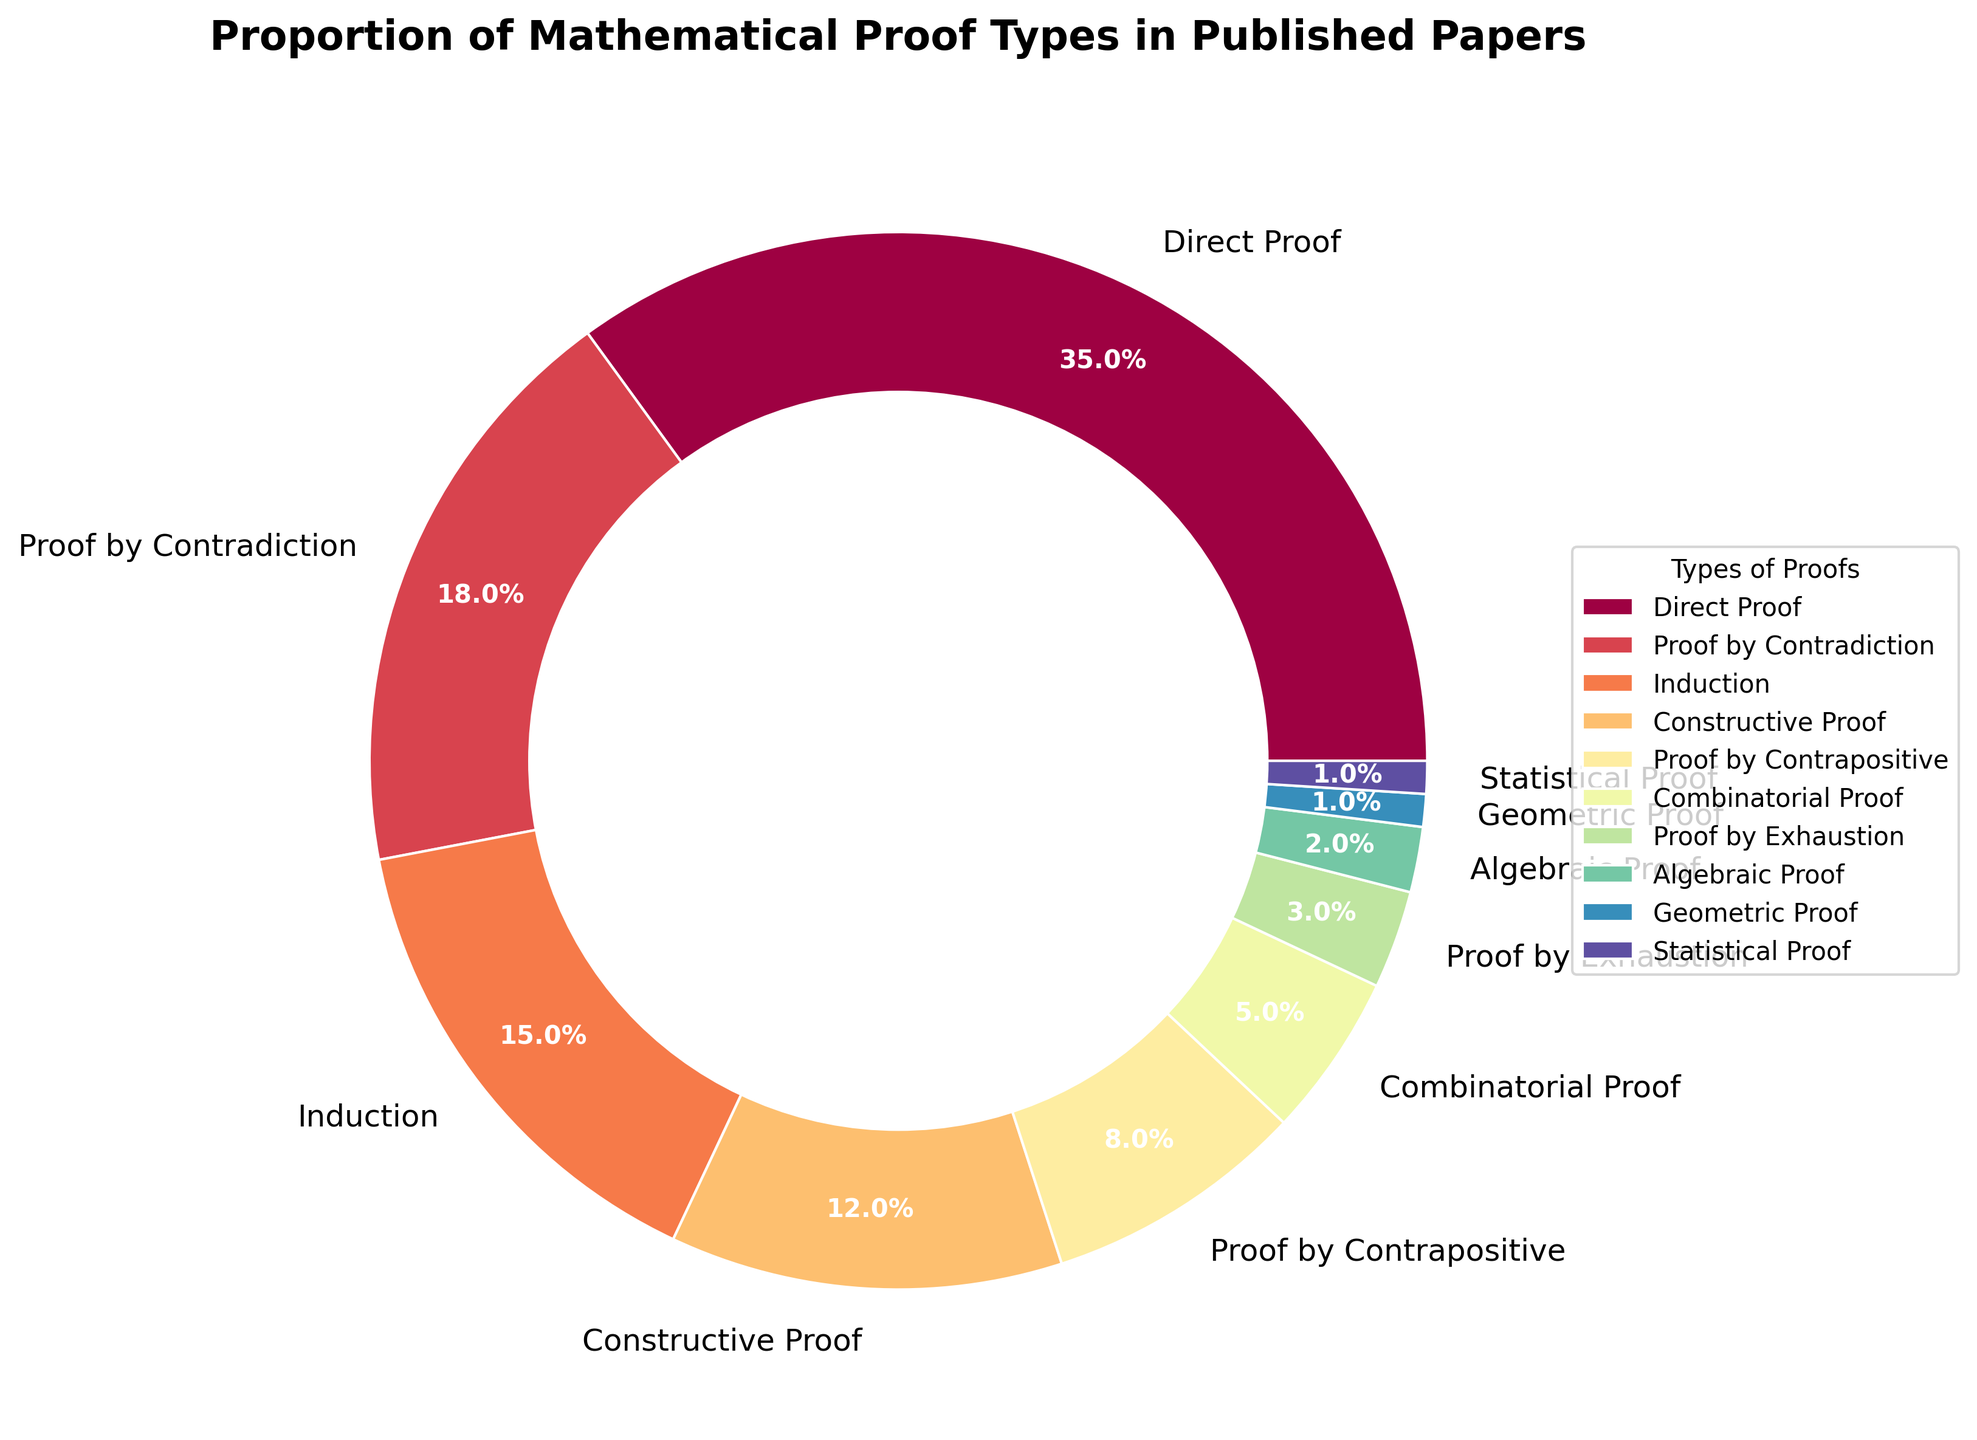What's the sum of the percentages of Direct Proof and Proof by Induction? To find the sum, add the percentages of 'Direct Proof' (35%) and 'Induction' (15%). 35% + 15% = 50%
Answer: 50% Which type of proof has the second-highest percentage? Examine the pie chart and identify the proof types with their respective percentages. The second-highest percentage is 18%, corresponding to 'Proof by Contradiction'.
Answer: Proof by Contradiction What is the difference in percentage between the Geometric Proof and the Algebraic Proof? Subtract the percentage of 'Geometric Proof' (1%) from that of 'Algebraic Proof' (2%). 2% - 1% = 1%
Answer: 1% Which type of proof has a larger proportion, Proof by Exhaustion or Constructive Proof, and by how much? Compare the percentages of 'Proof by Exhaustion' (3%) and 'Constructive Proof' (12%). Subtract the smaller percentage from the larger one. 12% - 3% = 9%
Answer: Constructive Proof by 9% What is the combined percentage of the least three frequent types of proofs? Identify the least three frequent types of proofs: 'Geometric Proof' (1%), 'Statistical Proof' (1%), and 'Algebraic Proof' (2%). Sum these percentages. 1% + 1% + 2% = 4%
Answer: 4% Which color represents Proof by Contrapositive and what is its approximate percentage? Look for the appropriate color and percentage from the legend and pie chart. 'Proof by Contrapositive' is represented by the color in the middle of the spectrum and has an 8% proportion.
Answer: The middle spectrum color, 8% What is the average percentage of the top four most frequent types of proofs? Identify the top four proofs: 'Direct Proof' (35%), 'Proof by Contradiction' (18%), 'Induction' (15%), 'Constructive Proof' (12%). Calculate the average: (35% + 18% + 15% + 12%) / 4 = 80% / 4 = 20%
Answer: 20% Is the percentage of Statistical Proofs greater than, less than, or equal to the percentage of Geometric Proofs? Compare the percentages of 'Statistical Proof' (1%) and 'Geometric Proof' (1%). They are equal.
Answer: Equal By how much does the combined percentage of Combinatorial Proof and Proof by Exhaustion exceed the percentage of Proof by Contradiction? First, sum the percentages of 'Combinatorial Proof' (5%) and 'Proof by Exhaustion' (3%): 5% + 3% = 8%. Then, subtract the percentage of 'Proof by Contradiction' (18%): 8% - 18% = -10%. Therefore, it does not exceed but is less by 10%.
Answer: Less by 10% What is the proportion of the total for Induction and Proof by Contrapositive combined relative to Direct Proof? Sum the percentages of 'Induction' (15%) and 'Proof by Contrapositive' (8%): 15% + 8% = 23%. Then, find the ratio relative to 'Direct Proof' (35%): 23% / 35% = 0.657 or approximately 65.7%.
Answer: Approximately 65.7% 